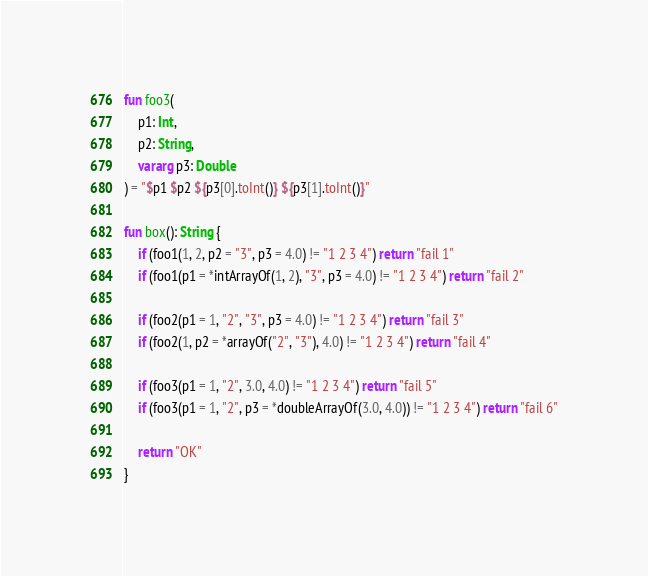Convert code to text. <code><loc_0><loc_0><loc_500><loc_500><_Kotlin_>
fun foo3(
    p1: Int,
    p2: String,
    vararg p3: Double
) = "$p1 $p2 ${p3[0].toInt()} ${p3[1].toInt()}"

fun box(): String {
    if (foo1(1, 2, p2 = "3", p3 = 4.0) != "1 2 3 4") return "fail 1"
    if (foo1(p1 = *intArrayOf(1, 2), "3", p3 = 4.0) != "1 2 3 4") return "fail 2"

    if (foo2(p1 = 1, "2", "3", p3 = 4.0) != "1 2 3 4") return "fail 3"
    if (foo2(1, p2 = *arrayOf("2", "3"), 4.0) != "1 2 3 4") return "fail 4"

    if (foo3(p1 = 1, "2", 3.0, 4.0) != "1 2 3 4") return "fail 5"
    if (foo3(p1 = 1, "2", p3 = *doubleArrayOf(3.0, 4.0)) != "1 2 3 4") return "fail 6"

    return "OK"
}
</code> 